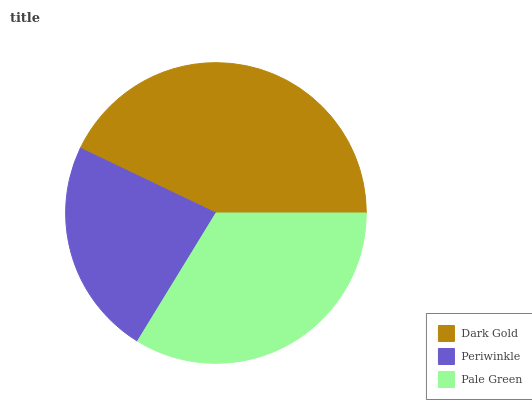Is Periwinkle the minimum?
Answer yes or no. Yes. Is Dark Gold the maximum?
Answer yes or no. Yes. Is Pale Green the minimum?
Answer yes or no. No. Is Pale Green the maximum?
Answer yes or no. No. Is Pale Green greater than Periwinkle?
Answer yes or no. Yes. Is Periwinkle less than Pale Green?
Answer yes or no. Yes. Is Periwinkle greater than Pale Green?
Answer yes or no. No. Is Pale Green less than Periwinkle?
Answer yes or no. No. Is Pale Green the high median?
Answer yes or no. Yes. Is Pale Green the low median?
Answer yes or no. Yes. Is Dark Gold the high median?
Answer yes or no. No. Is Dark Gold the low median?
Answer yes or no. No. 